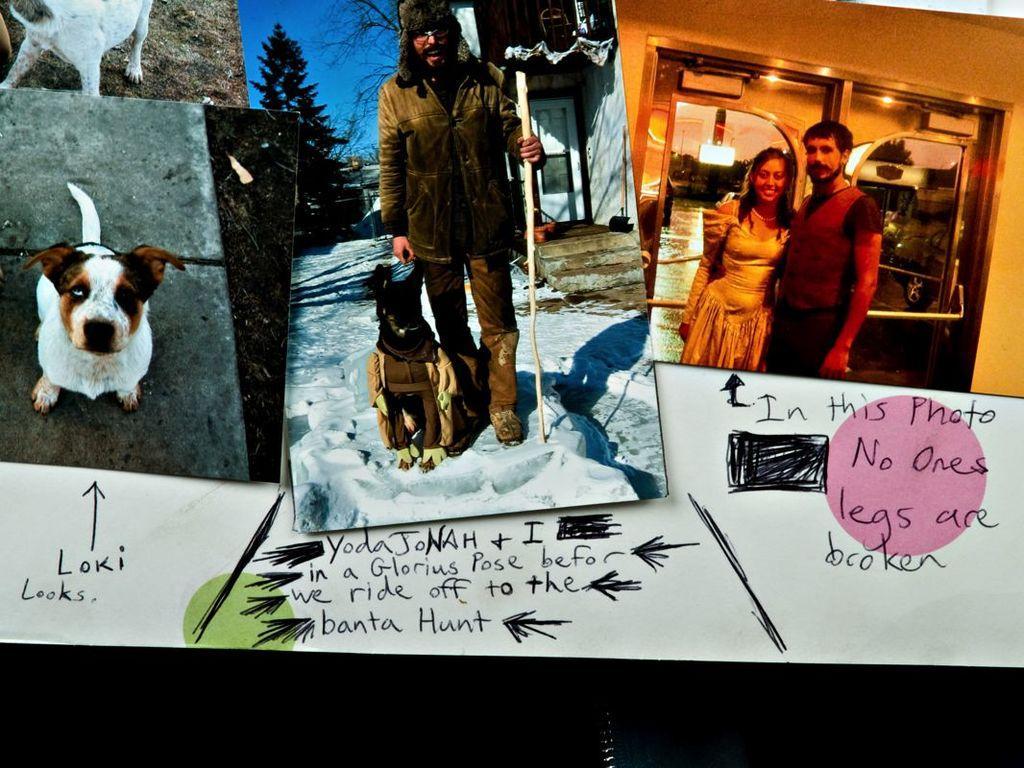How would you summarize this image in a sentence or two? In this image I can see few different photos on the white color surface and I can see few persons standing in the photos and I can see the dog in white and brown color. Background I can see few lights, plants in green color and the sky is in blue color. 